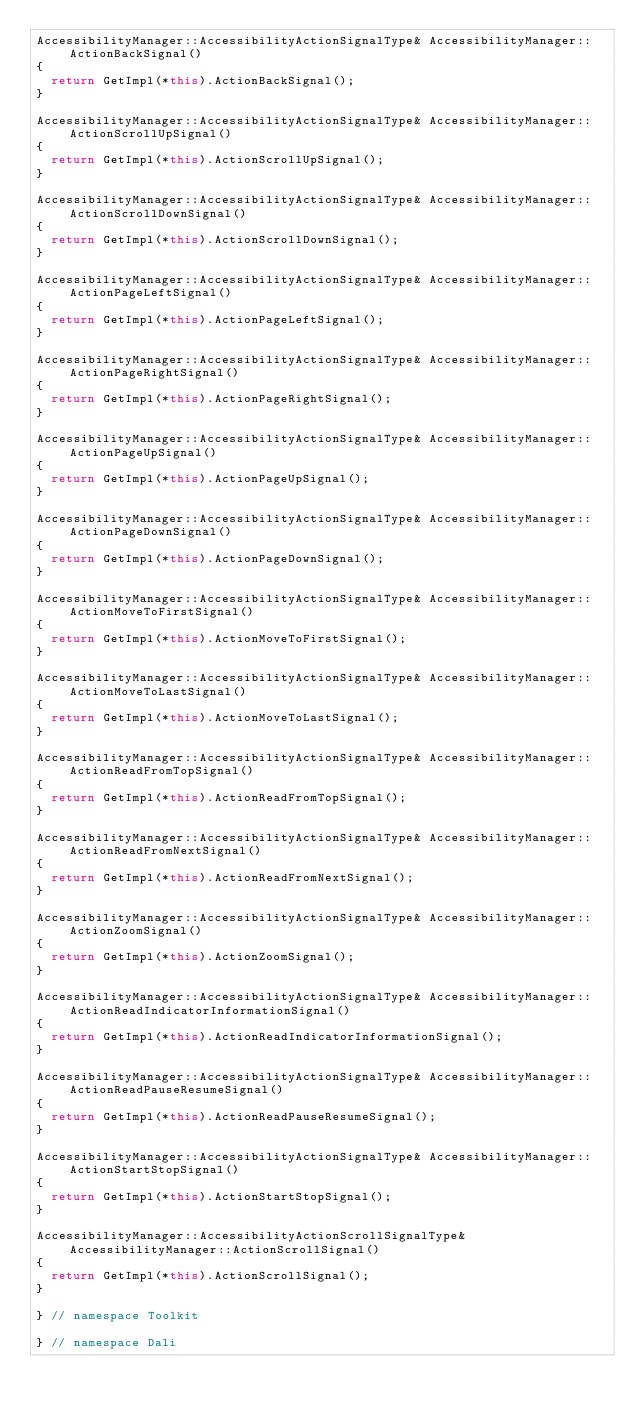<code> <loc_0><loc_0><loc_500><loc_500><_C++_>AccessibilityManager::AccessibilityActionSignalType& AccessibilityManager::ActionBackSignal()
{
  return GetImpl(*this).ActionBackSignal();
}

AccessibilityManager::AccessibilityActionSignalType& AccessibilityManager::ActionScrollUpSignal()
{
  return GetImpl(*this).ActionScrollUpSignal();
}

AccessibilityManager::AccessibilityActionSignalType& AccessibilityManager::ActionScrollDownSignal()
{
  return GetImpl(*this).ActionScrollDownSignal();
}

AccessibilityManager::AccessibilityActionSignalType& AccessibilityManager::ActionPageLeftSignal()
{
  return GetImpl(*this).ActionPageLeftSignal();
}

AccessibilityManager::AccessibilityActionSignalType& AccessibilityManager::ActionPageRightSignal()
{
  return GetImpl(*this).ActionPageRightSignal();
}

AccessibilityManager::AccessibilityActionSignalType& AccessibilityManager::ActionPageUpSignal()
{
  return GetImpl(*this).ActionPageUpSignal();
}

AccessibilityManager::AccessibilityActionSignalType& AccessibilityManager::ActionPageDownSignal()
{
  return GetImpl(*this).ActionPageDownSignal();
}

AccessibilityManager::AccessibilityActionSignalType& AccessibilityManager::ActionMoveToFirstSignal()
{
  return GetImpl(*this).ActionMoveToFirstSignal();
}

AccessibilityManager::AccessibilityActionSignalType& AccessibilityManager::ActionMoveToLastSignal()
{
  return GetImpl(*this).ActionMoveToLastSignal();
}

AccessibilityManager::AccessibilityActionSignalType& AccessibilityManager::ActionReadFromTopSignal()
{
  return GetImpl(*this).ActionReadFromTopSignal();
}

AccessibilityManager::AccessibilityActionSignalType& AccessibilityManager::ActionReadFromNextSignal()
{
  return GetImpl(*this).ActionReadFromNextSignal();
}

AccessibilityManager::AccessibilityActionSignalType& AccessibilityManager::ActionZoomSignal()
{
  return GetImpl(*this).ActionZoomSignal();
}

AccessibilityManager::AccessibilityActionSignalType& AccessibilityManager::ActionReadIndicatorInformationSignal()
{
  return GetImpl(*this).ActionReadIndicatorInformationSignal();
}

AccessibilityManager::AccessibilityActionSignalType& AccessibilityManager::ActionReadPauseResumeSignal()
{
  return GetImpl(*this).ActionReadPauseResumeSignal();
}

AccessibilityManager::AccessibilityActionSignalType& AccessibilityManager::ActionStartStopSignal()
{
  return GetImpl(*this).ActionStartStopSignal();
}

AccessibilityManager::AccessibilityActionScrollSignalType& AccessibilityManager::ActionScrollSignal()
{
  return GetImpl(*this).ActionScrollSignal();
}

} // namespace Toolkit

} // namespace Dali
</code> 